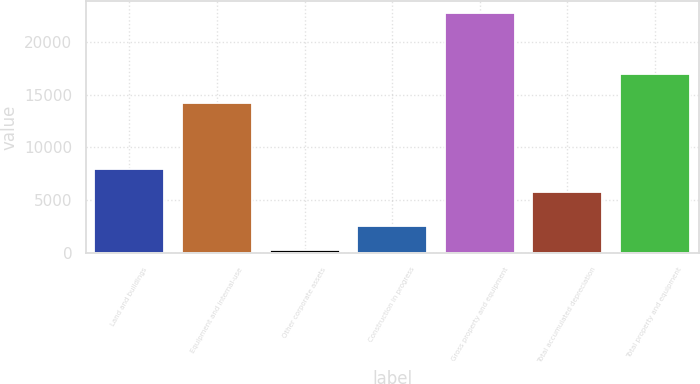Convert chart to OTSL. <chart><loc_0><loc_0><loc_500><loc_500><bar_chart><fcel>Land and buildings<fcel>Equipment and internal-use<fcel>Other corporate assets<fcel>Construction in progress<fcel>Gross property and equipment<fcel>Total accumulated depreciation<fcel>Total property and equipment<nl><fcel>8005.6<fcel>14213<fcel>304<fcel>2546.6<fcel>22730<fcel>5763<fcel>16967<nl></chart> 